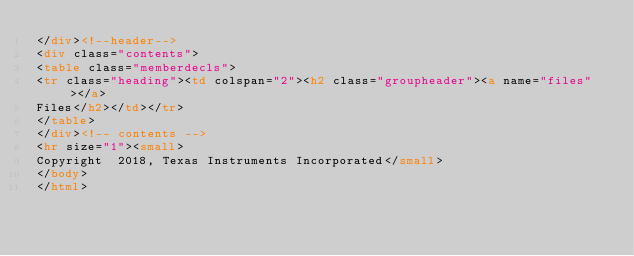Convert code to text. <code><loc_0><loc_0><loc_500><loc_500><_HTML_></div><!--header-->
<div class="contents">
<table class="memberdecls">
<tr class="heading"><td colspan="2"><h2 class="groupheader"><a name="files"></a>
Files</h2></td></tr>
</table>
</div><!-- contents -->
<hr size="1"><small>
Copyright  2018, Texas Instruments Incorporated</small>
</body>
</html>
</code> 